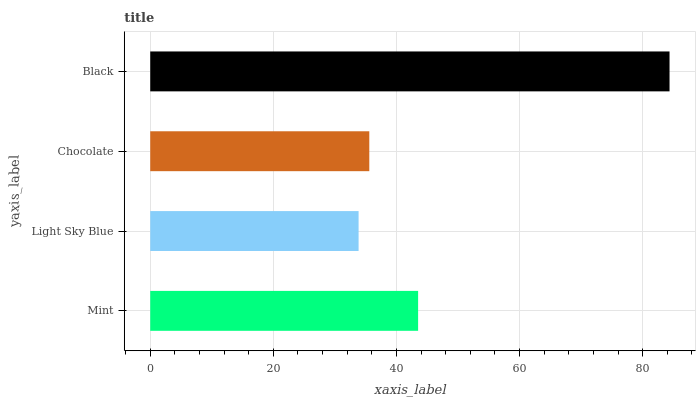Is Light Sky Blue the minimum?
Answer yes or no. Yes. Is Black the maximum?
Answer yes or no. Yes. Is Chocolate the minimum?
Answer yes or no. No. Is Chocolate the maximum?
Answer yes or no. No. Is Chocolate greater than Light Sky Blue?
Answer yes or no. Yes. Is Light Sky Blue less than Chocolate?
Answer yes or no. Yes. Is Light Sky Blue greater than Chocolate?
Answer yes or no. No. Is Chocolate less than Light Sky Blue?
Answer yes or no. No. Is Mint the high median?
Answer yes or no. Yes. Is Chocolate the low median?
Answer yes or no. Yes. Is Black the high median?
Answer yes or no. No. Is Light Sky Blue the low median?
Answer yes or no. No. 